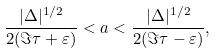Convert formula to latex. <formula><loc_0><loc_0><loc_500><loc_500>\frac { | \Delta | ^ { 1 / 2 } } { 2 ( \Im \tau + \varepsilon ) } < a < \frac { | \Delta | ^ { 1 / 2 } } { 2 ( \Im \tau - \varepsilon ) } ,</formula> 